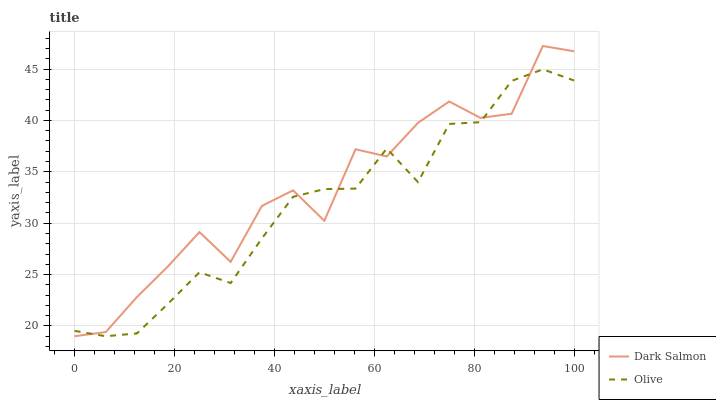Does Olive have the minimum area under the curve?
Answer yes or no. Yes. Does Dark Salmon have the maximum area under the curve?
Answer yes or no. Yes. Does Dark Salmon have the minimum area under the curve?
Answer yes or no. No. Is Olive the smoothest?
Answer yes or no. Yes. Is Dark Salmon the roughest?
Answer yes or no. Yes. Is Dark Salmon the smoothest?
Answer yes or no. No. Does Olive have the lowest value?
Answer yes or no. Yes. Does Dark Salmon have the highest value?
Answer yes or no. Yes. Does Dark Salmon intersect Olive?
Answer yes or no. Yes. Is Dark Salmon less than Olive?
Answer yes or no. No. Is Dark Salmon greater than Olive?
Answer yes or no. No. 